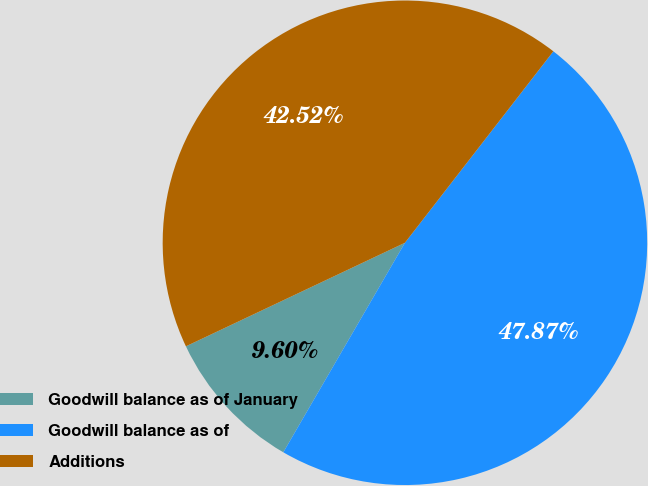<chart> <loc_0><loc_0><loc_500><loc_500><pie_chart><fcel>Goodwill balance as of January<fcel>Goodwill balance as of<fcel>Additions<nl><fcel>9.6%<fcel>47.87%<fcel>42.52%<nl></chart> 